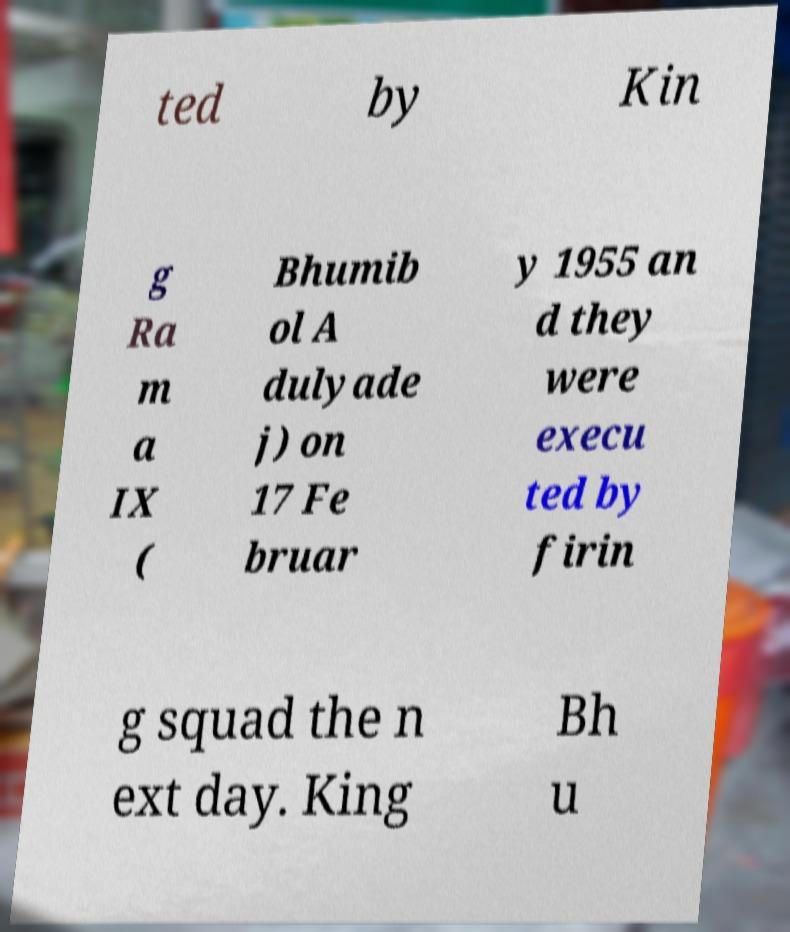There's text embedded in this image that I need extracted. Can you transcribe it verbatim? ted by Kin g Ra m a IX ( Bhumib ol A dulyade j) on 17 Fe bruar y 1955 an d they were execu ted by firin g squad the n ext day. King Bh u 